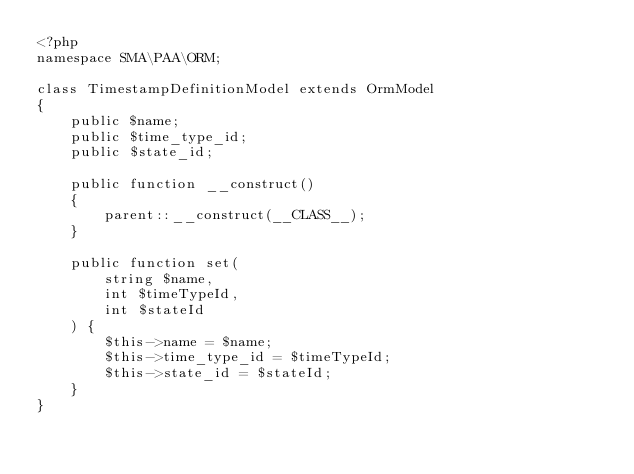<code> <loc_0><loc_0><loc_500><loc_500><_PHP_><?php
namespace SMA\PAA\ORM;

class TimestampDefinitionModel extends OrmModel
{
    public $name;
    public $time_type_id;
    public $state_id;

    public function __construct()
    {
        parent::__construct(__CLASS__);
    }

    public function set(
        string $name,
        int $timeTypeId,
        int $stateId
    ) {
        $this->name = $name;
        $this->time_type_id = $timeTypeId;
        $this->state_id = $stateId;
    }
}
</code> 